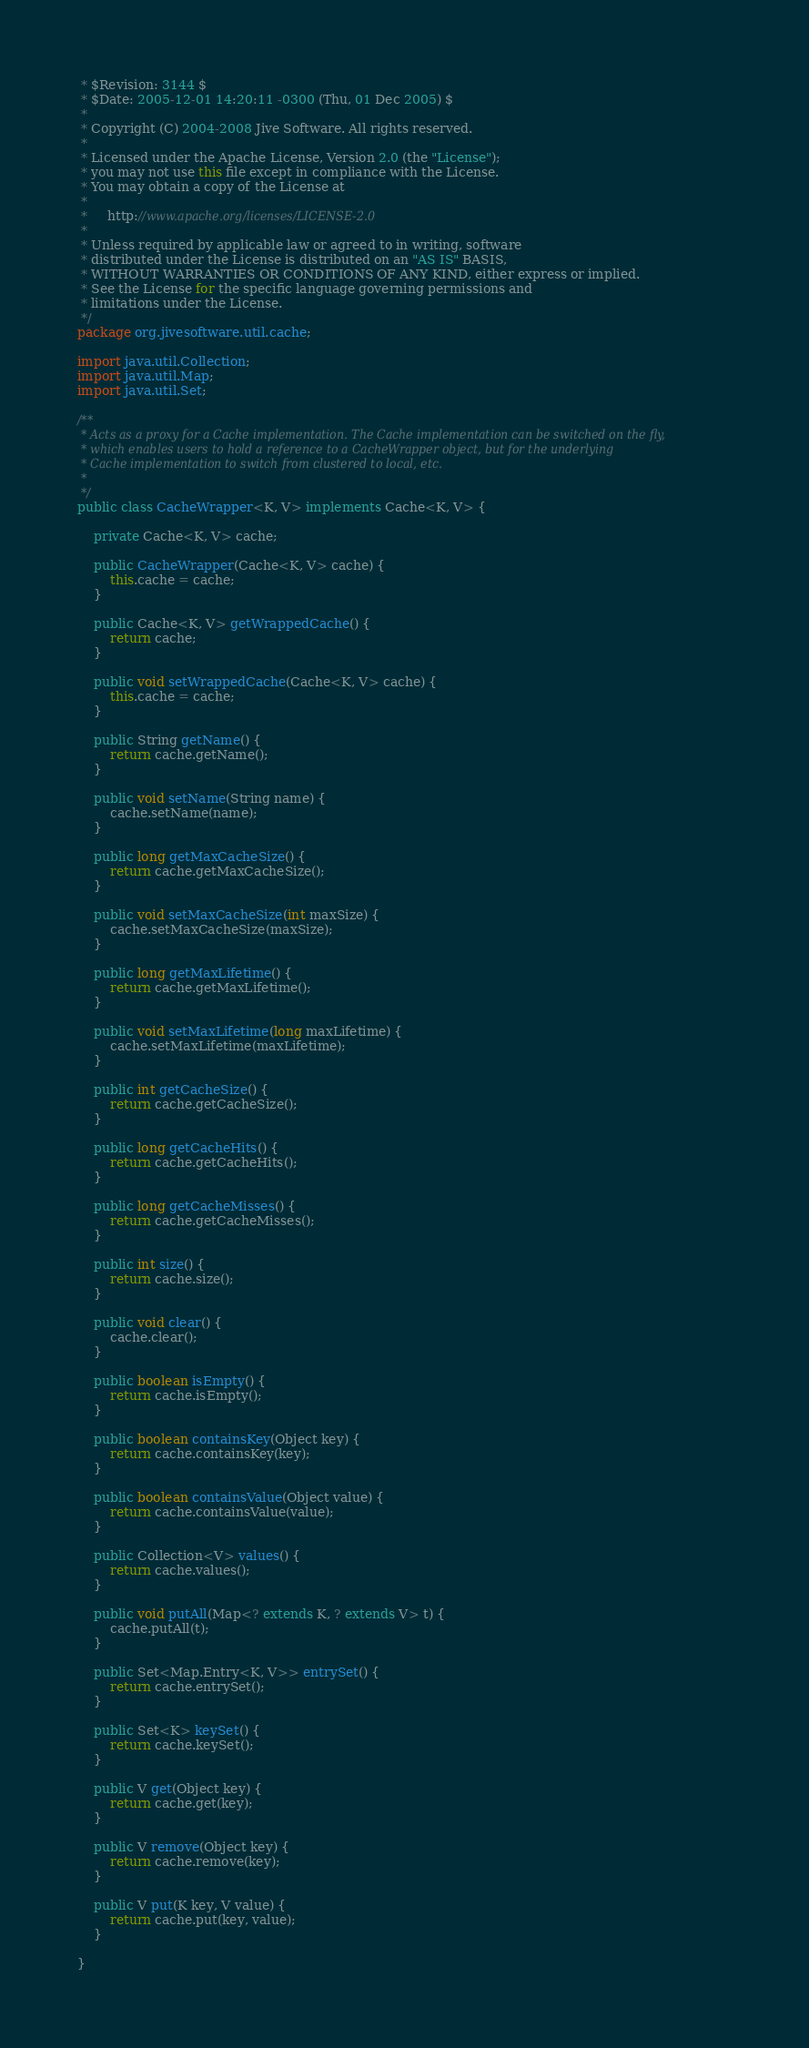Convert code to text. <code><loc_0><loc_0><loc_500><loc_500><_Java_> * $Revision: 3144 $
 * $Date: 2005-12-01 14:20:11 -0300 (Thu, 01 Dec 2005) $
 *
 * Copyright (C) 2004-2008 Jive Software. All rights reserved.
 *
 * Licensed under the Apache License, Version 2.0 (the "License");
 * you may not use this file except in compliance with the License.
 * You may obtain a copy of the License at
 *
 *     http://www.apache.org/licenses/LICENSE-2.0
 *
 * Unless required by applicable law or agreed to in writing, software
 * distributed under the License is distributed on an "AS IS" BASIS,
 * WITHOUT WARRANTIES OR CONDITIONS OF ANY KIND, either express or implied.
 * See the License for the specific language governing permissions and
 * limitations under the License.
 */
package org.jivesoftware.util.cache;

import java.util.Collection;
import java.util.Map;
import java.util.Set;

/**
 * Acts as a proxy for a Cache implementation. The Cache implementation can be switched on the fly,
 * which enables users to hold a reference to a CacheWrapper object, but for the underlying
 * Cache implementation to switch from clustered to local, etc.
 *
 */
public class CacheWrapper<K, V> implements Cache<K, V> {

    private Cache<K, V> cache;

    public CacheWrapper(Cache<K, V> cache) {
        this.cache = cache;
    }

    public Cache<K, V> getWrappedCache() {
        return cache;
    }

    public void setWrappedCache(Cache<K, V> cache) {
        this.cache = cache;
    }

    public String getName() {
        return cache.getName();
    }

    public void setName(String name) {
        cache.setName(name);
    }

    public long getMaxCacheSize() {
        return cache.getMaxCacheSize();
    }

    public void setMaxCacheSize(int maxSize) {
        cache.setMaxCacheSize(maxSize);
    }

    public long getMaxLifetime() {
        return cache.getMaxLifetime();
    }

    public void setMaxLifetime(long maxLifetime) {
        cache.setMaxLifetime(maxLifetime);
    }

    public int getCacheSize() {
        return cache.getCacheSize();
    }

    public long getCacheHits() {
        return cache.getCacheHits();
    }

    public long getCacheMisses() {
        return cache.getCacheMisses();
    }

    public int size() {
        return cache.size();
    }

    public void clear() {
        cache.clear();
    }

    public boolean isEmpty() {
        return cache.isEmpty();
    }

    public boolean containsKey(Object key) {
        return cache.containsKey(key);
    }

    public boolean containsValue(Object value) {
        return cache.containsValue(value);
    }

    public Collection<V> values() {
        return cache.values();
    }

    public void putAll(Map<? extends K, ? extends V> t) {
        cache.putAll(t);
    }

    public Set<Map.Entry<K, V>> entrySet() {
        return cache.entrySet();
    }

    public Set<K> keySet() {
        return cache.keySet();
    }

    public V get(Object key) {
        return cache.get(key);
    }

    public V remove(Object key) {
        return cache.remove(key);
    }

    public V put(K key, V value) {
        return cache.put(key, value);
    }

}</code> 